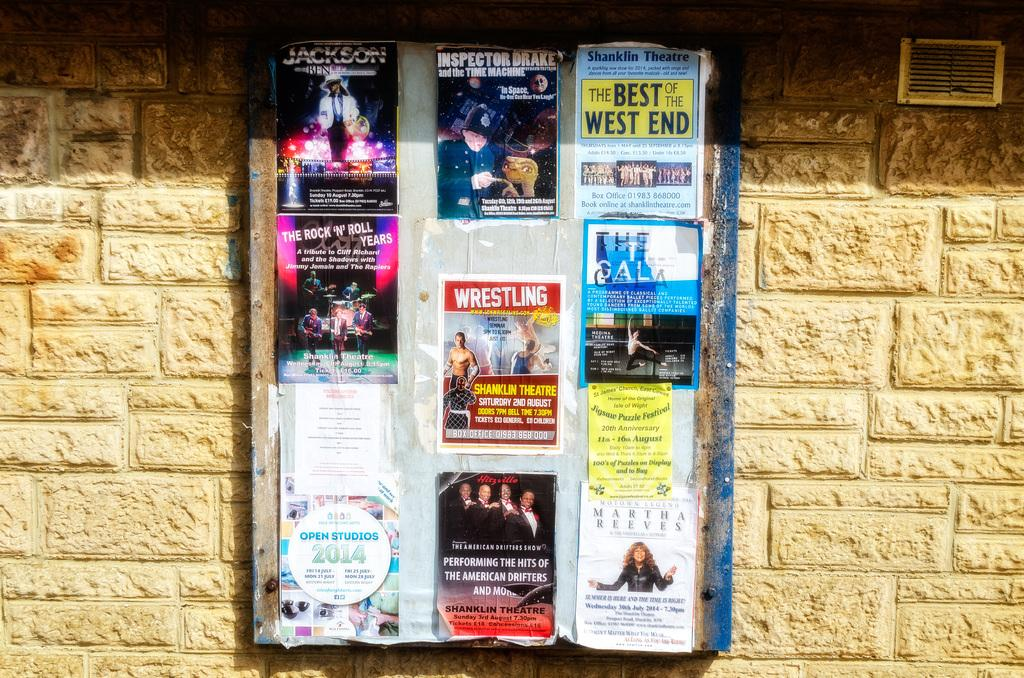<image>
Render a clear and concise summary of the photo. A bulletin board with several pamphlets including one that is titled Wrestling. 